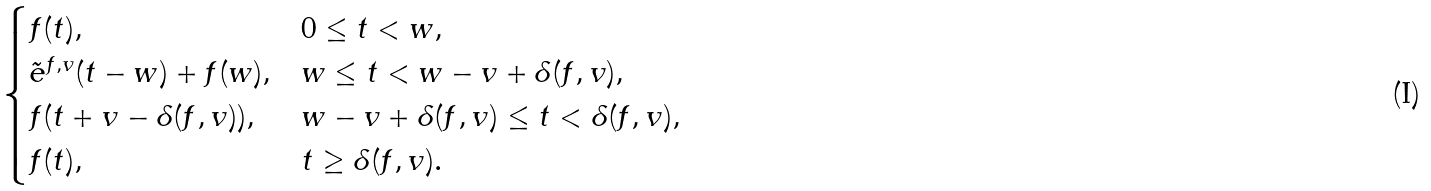<formula> <loc_0><loc_0><loc_500><loc_500>\begin{cases} f ( t ) , & 0 \leq t < w , \\ \tilde { e } ^ { f , v } ( t - w ) + f ( w ) , & w \leq t < w - v + \delta ( f , v ) , \\ f ( t + v - \delta ( f , v ) ) , & w - v + \delta ( f , v ) \leq t < \delta ( f , v ) , \\ f ( t ) , & t \geq \delta ( f , v ) . \\ \end{cases}</formula> 